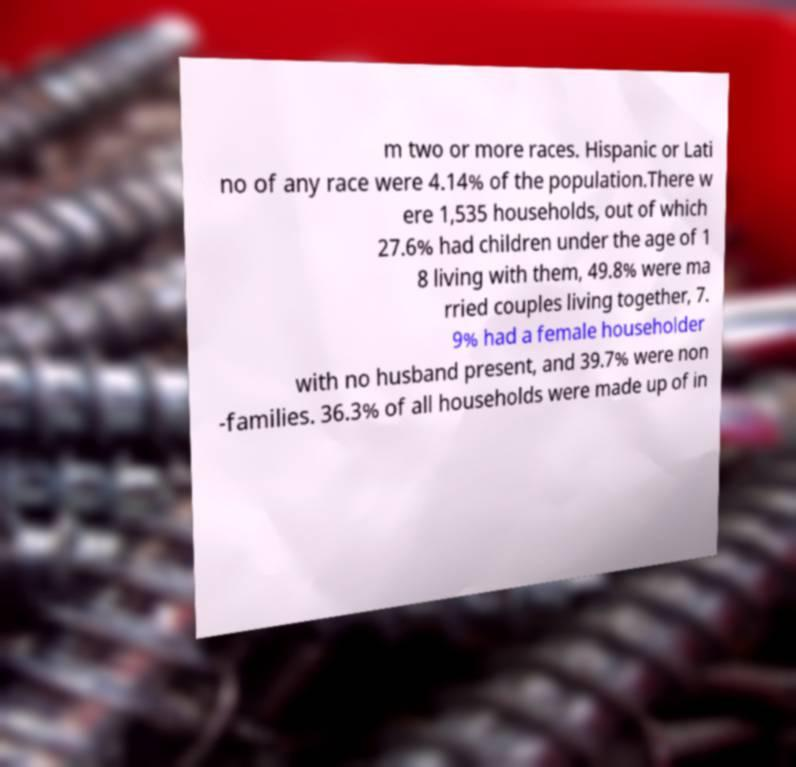There's text embedded in this image that I need extracted. Can you transcribe it verbatim? m two or more races. Hispanic or Lati no of any race were 4.14% of the population.There w ere 1,535 households, out of which 27.6% had children under the age of 1 8 living with them, 49.8% were ma rried couples living together, 7. 9% had a female householder with no husband present, and 39.7% were non -families. 36.3% of all households were made up of in 